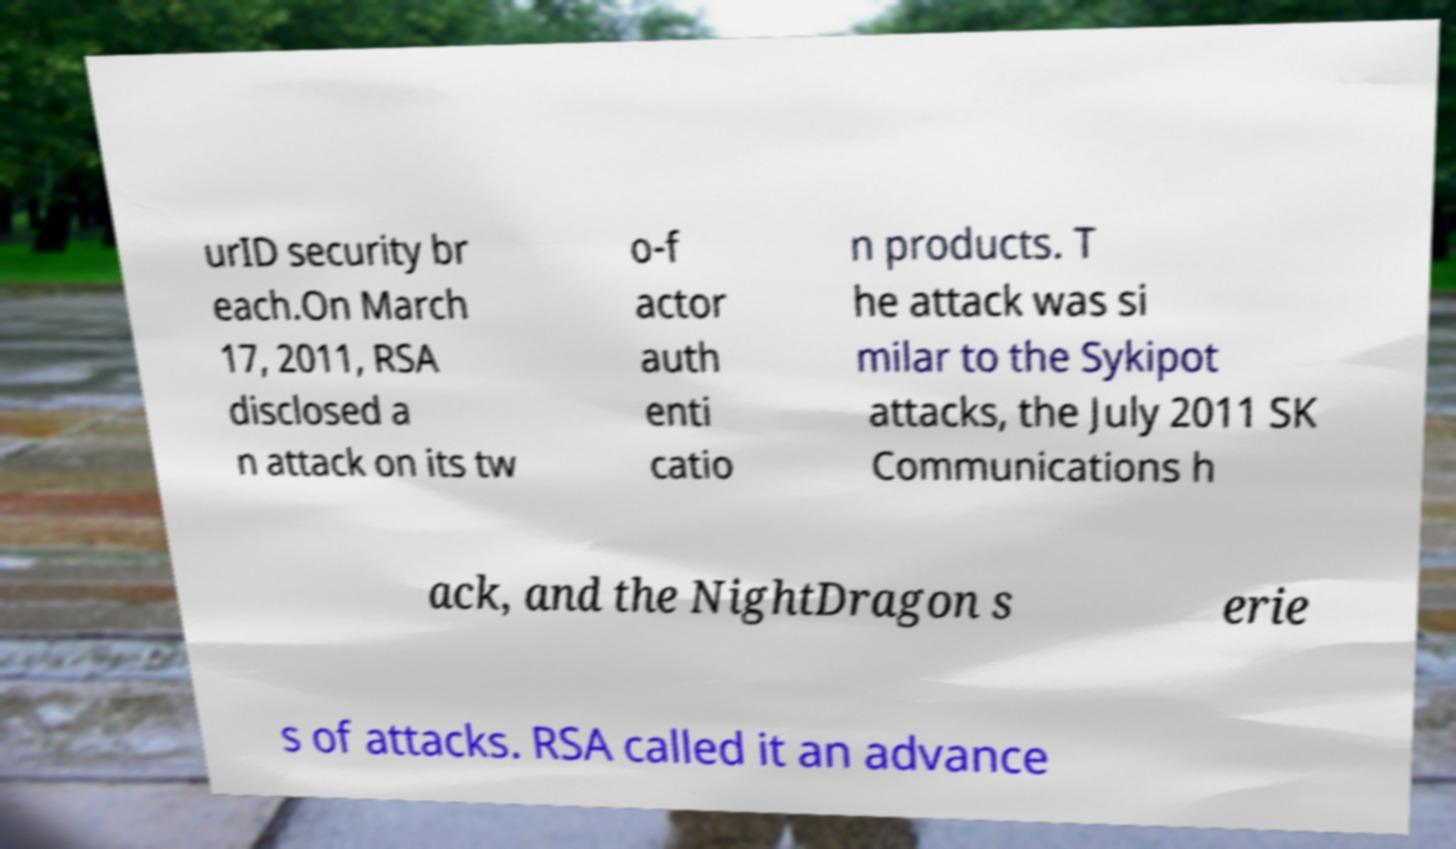I need the written content from this picture converted into text. Can you do that? urID security br each.On March 17, 2011, RSA disclosed a n attack on its tw o-f actor auth enti catio n products. T he attack was si milar to the Sykipot attacks, the July 2011 SK Communications h ack, and the NightDragon s erie s of attacks. RSA called it an advance 